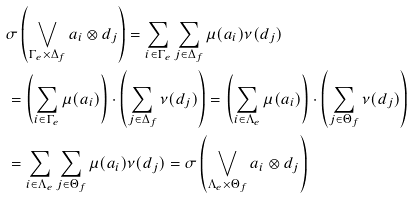Convert formula to latex. <formula><loc_0><loc_0><loc_500><loc_500>& \sigma \left ( \bigvee _ { \Gamma _ { e } \times \Delta _ { f } } a _ { i } \otimes d _ { j } \right ) = \sum _ { i \in \Gamma _ { e } } \sum _ { j \in \Delta _ { f } } \mu ( a _ { i } ) \nu ( d _ { j } ) \\ & = \left ( \sum _ { i \in \Gamma _ { e } } \mu ( a _ { i } ) \right ) \cdot \left ( \sum _ { j \in \Delta _ { f } } \nu ( d _ { j } ) \right ) = \left ( \sum _ { i \in \Lambda _ { e } } \mu ( a _ { i } ) \right ) \cdot \left ( \sum _ { j \in \Theta _ { f } } \nu ( d _ { j } ) \right ) \\ & = \sum _ { i \in \Lambda _ { e } } \sum _ { j \in \Theta _ { f } } \mu ( a _ { i } ) \nu ( d _ { j } ) = \sigma \left ( \bigvee _ { \Lambda _ { e } \times \Theta _ { f } } a _ { i } \otimes d _ { j } \right )</formula> 